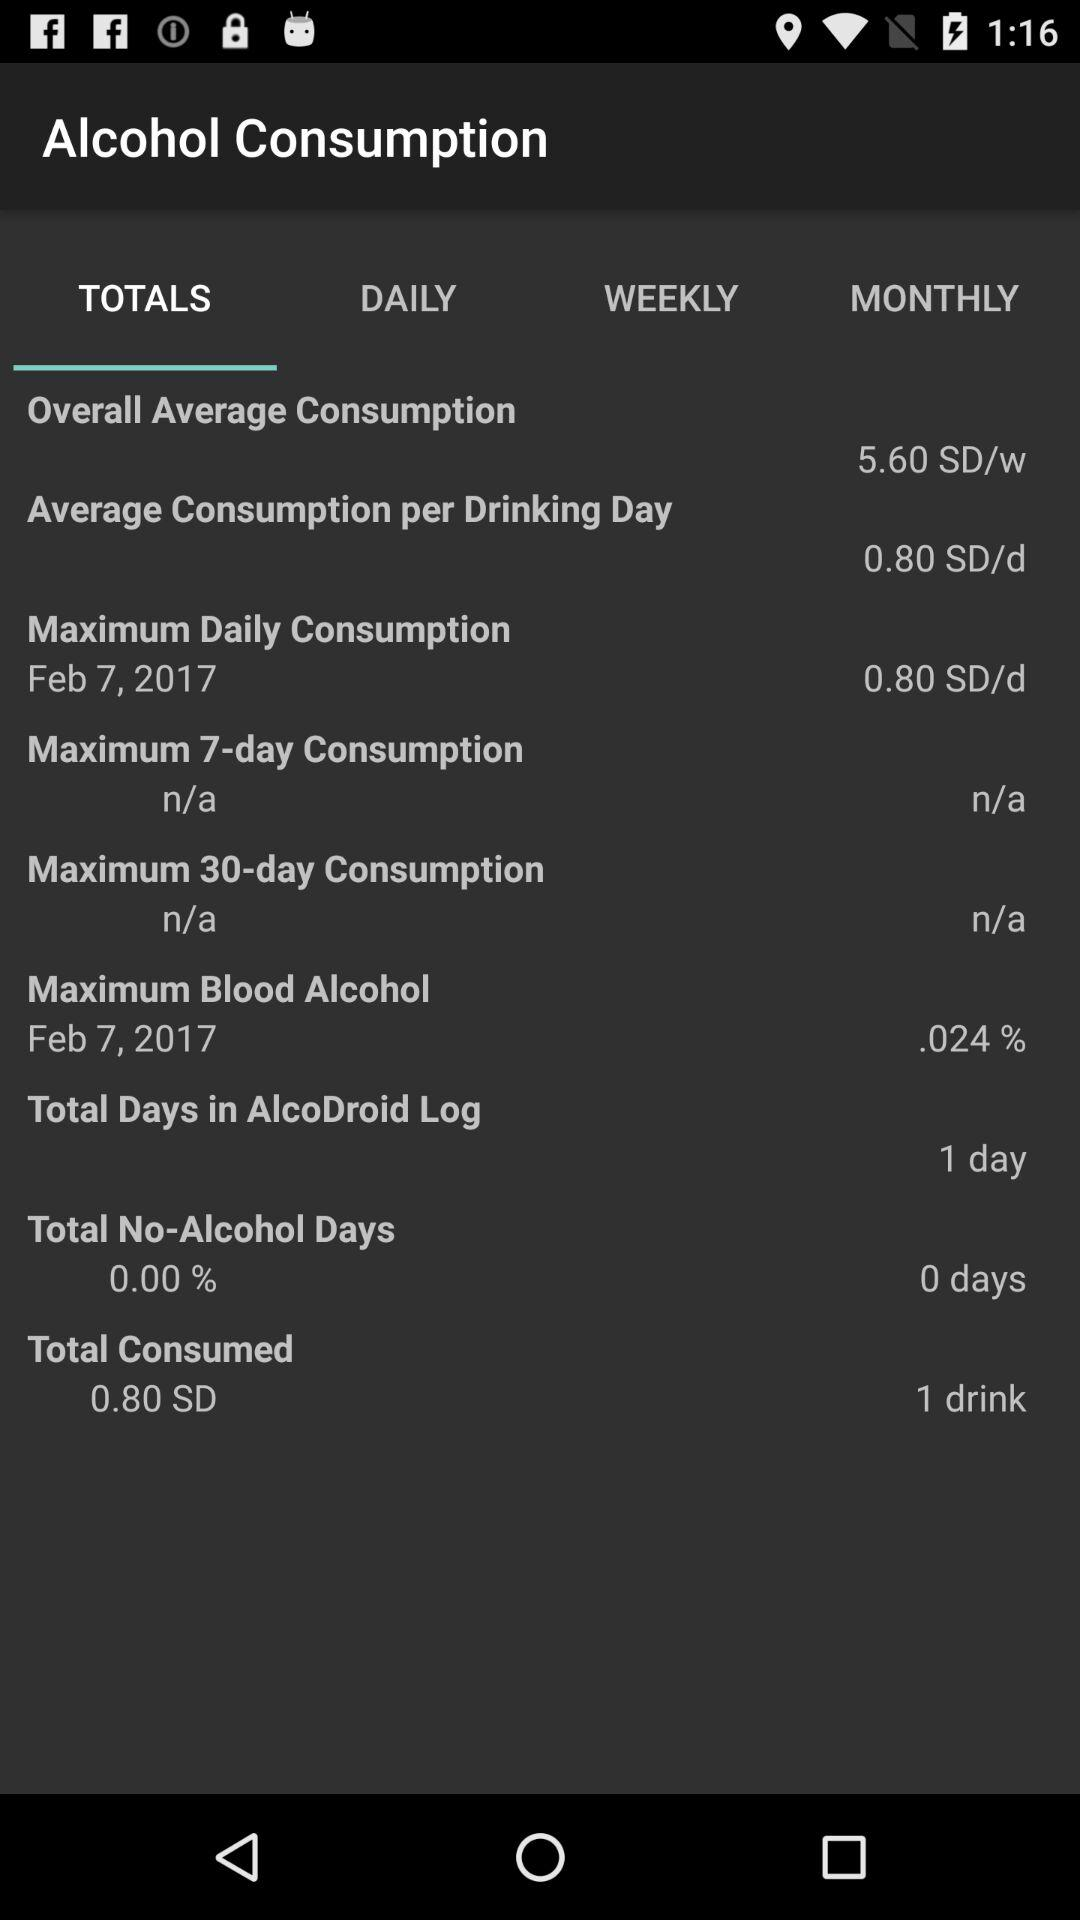What is the total number of drinks that were consumed? The total number of drinks that were consumed is 1. 